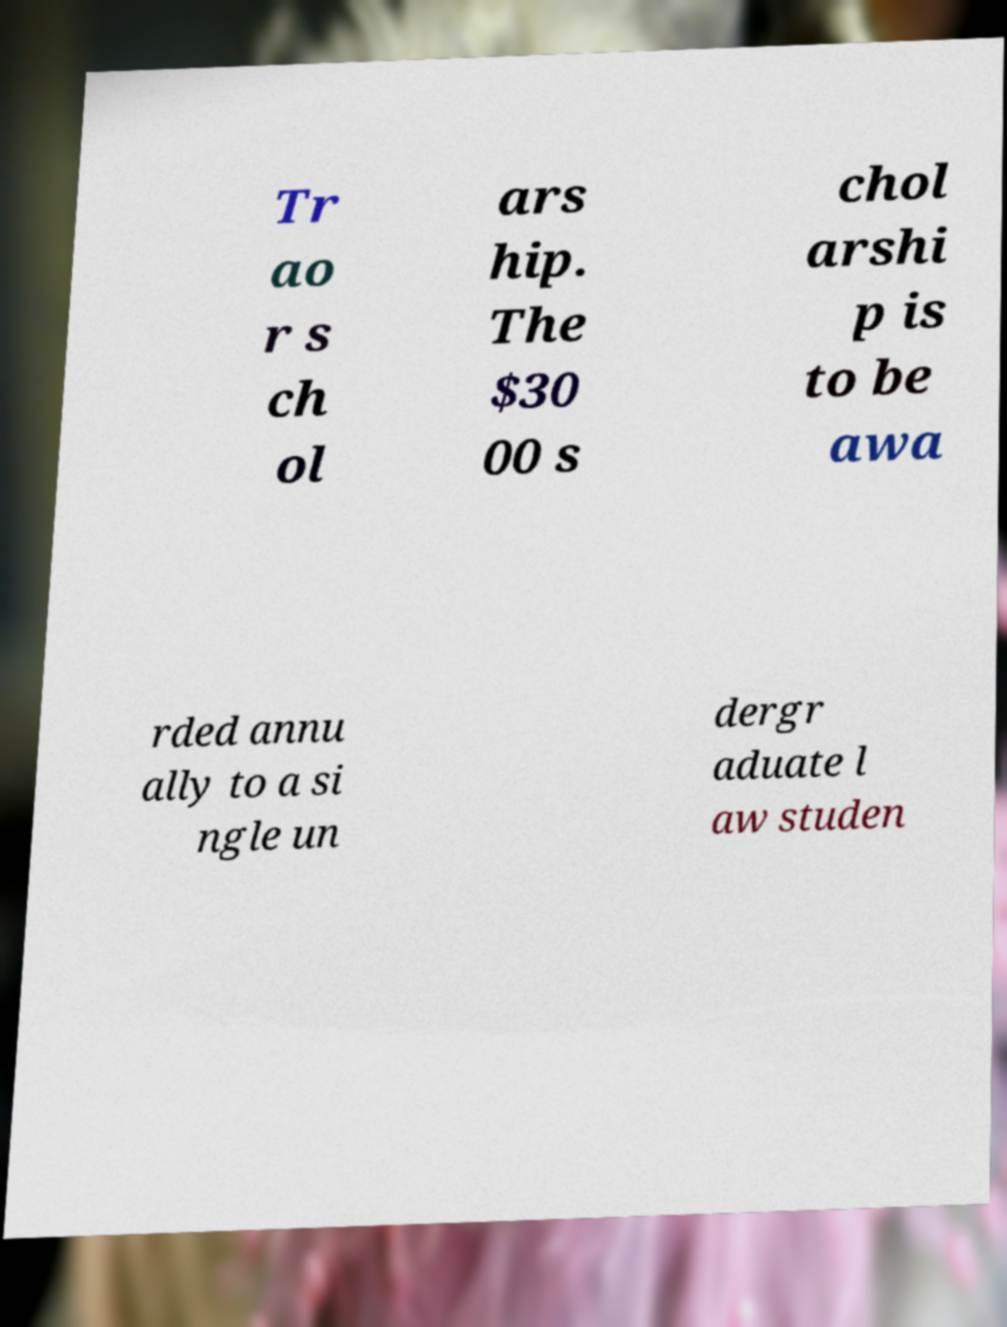Please identify and transcribe the text found in this image. Tr ao r s ch ol ars hip. The $30 00 s chol arshi p is to be awa rded annu ally to a si ngle un dergr aduate l aw studen 